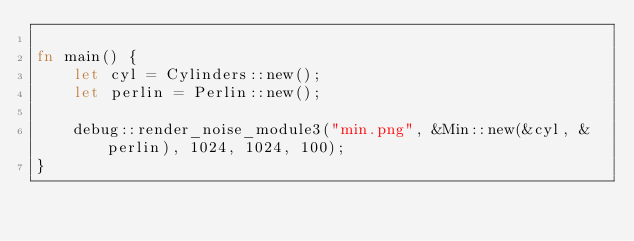Convert code to text. <code><loc_0><loc_0><loc_500><loc_500><_Rust_>
fn main() {
    let cyl = Cylinders::new();
    let perlin = Perlin::new();

    debug::render_noise_module3("min.png", &Min::new(&cyl, &perlin), 1024, 1024, 100);
}
</code> 